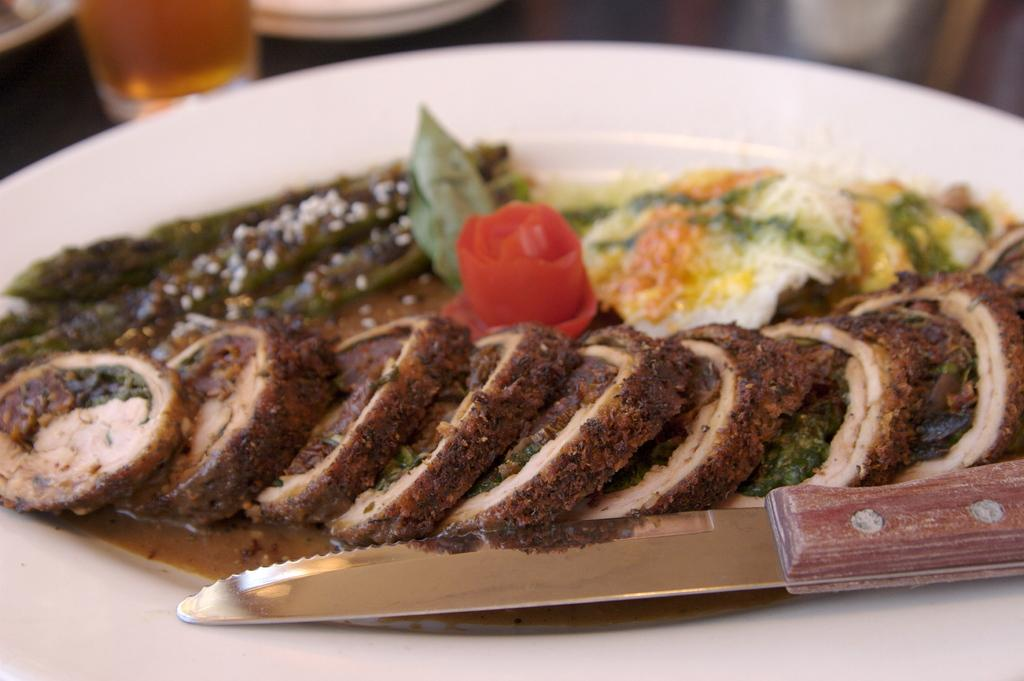What is on the plate in the image? There are food items on the plate in the image. What is located beside the plate? There is a glass beside the plate. What color is the plate in the image? The plate in the image is white. What time is displayed on the watch in the image? There is no watch present in the image. How does the spoon interact with the food items on the plate? There is no spoon present in the image; it only contains food items and a glass. 